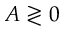Convert formula to latex. <formula><loc_0><loc_0><loc_500><loc_500>A \gtrless 0</formula> 